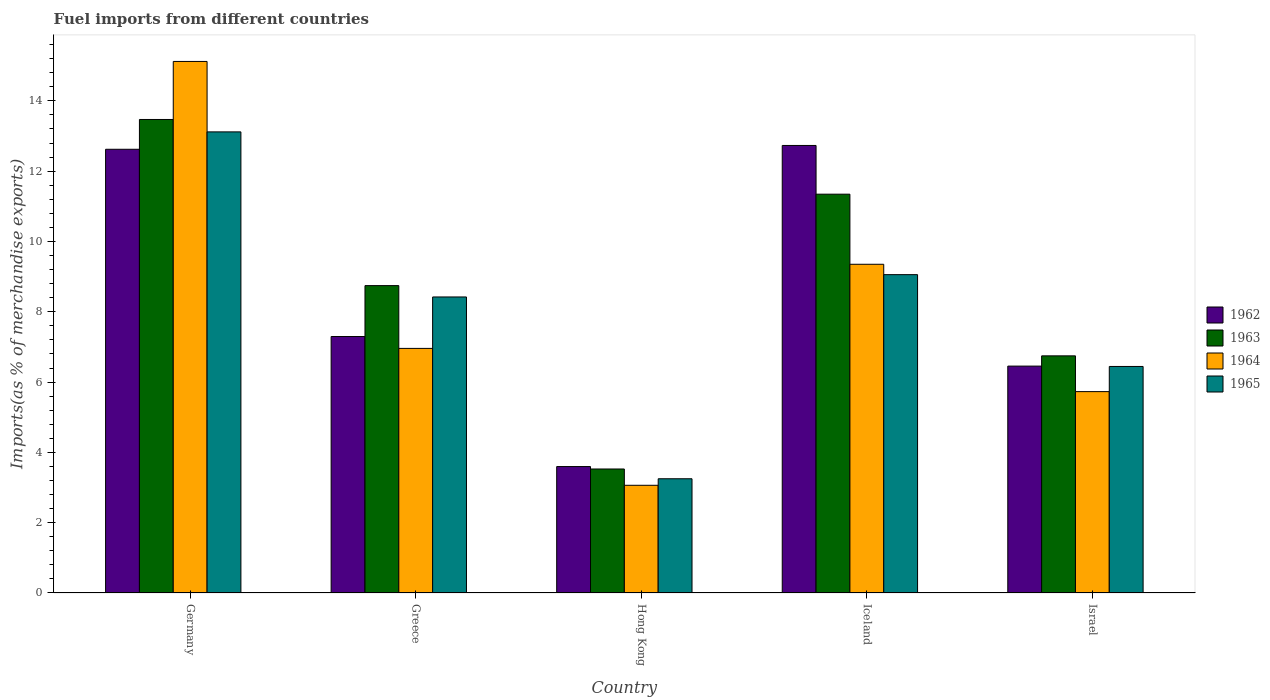How many groups of bars are there?
Offer a very short reply. 5. Are the number of bars per tick equal to the number of legend labels?
Offer a very short reply. Yes. How many bars are there on the 4th tick from the left?
Make the answer very short. 4. What is the percentage of imports to different countries in 1962 in Israel?
Make the answer very short. 6.45. Across all countries, what is the maximum percentage of imports to different countries in 1963?
Your answer should be very brief. 13.47. Across all countries, what is the minimum percentage of imports to different countries in 1964?
Offer a very short reply. 3.06. In which country was the percentage of imports to different countries in 1965 maximum?
Offer a very short reply. Germany. In which country was the percentage of imports to different countries in 1964 minimum?
Your answer should be very brief. Hong Kong. What is the total percentage of imports to different countries in 1962 in the graph?
Ensure brevity in your answer.  42.7. What is the difference between the percentage of imports to different countries in 1962 in Greece and that in Hong Kong?
Ensure brevity in your answer.  3.7. What is the difference between the percentage of imports to different countries in 1962 in Greece and the percentage of imports to different countries in 1965 in Israel?
Your answer should be compact. 0.85. What is the average percentage of imports to different countries in 1963 per country?
Your response must be concise. 8.77. What is the difference between the percentage of imports to different countries of/in 1963 and percentage of imports to different countries of/in 1965 in Hong Kong?
Ensure brevity in your answer.  0.28. In how many countries, is the percentage of imports to different countries in 1965 greater than 10 %?
Give a very brief answer. 1. What is the ratio of the percentage of imports to different countries in 1963 in Greece to that in Iceland?
Offer a terse response. 0.77. Is the difference between the percentage of imports to different countries in 1963 in Greece and Hong Kong greater than the difference between the percentage of imports to different countries in 1965 in Greece and Hong Kong?
Give a very brief answer. Yes. What is the difference between the highest and the second highest percentage of imports to different countries in 1963?
Ensure brevity in your answer.  -2.6. What is the difference between the highest and the lowest percentage of imports to different countries in 1962?
Offer a terse response. 9.13. Is it the case that in every country, the sum of the percentage of imports to different countries in 1963 and percentage of imports to different countries in 1962 is greater than the sum of percentage of imports to different countries in 1964 and percentage of imports to different countries in 1965?
Your answer should be compact. No. What does the 2nd bar from the left in Hong Kong represents?
Give a very brief answer. 1963. Are all the bars in the graph horizontal?
Provide a succinct answer. No. How many countries are there in the graph?
Provide a succinct answer. 5. Does the graph contain any zero values?
Your response must be concise. No. Where does the legend appear in the graph?
Provide a succinct answer. Center right. What is the title of the graph?
Give a very brief answer. Fuel imports from different countries. Does "2013" appear as one of the legend labels in the graph?
Provide a short and direct response. No. What is the label or title of the Y-axis?
Give a very brief answer. Imports(as % of merchandise exports). What is the Imports(as % of merchandise exports) in 1962 in Germany?
Ensure brevity in your answer.  12.62. What is the Imports(as % of merchandise exports) of 1963 in Germany?
Offer a terse response. 13.47. What is the Imports(as % of merchandise exports) in 1964 in Germany?
Your answer should be compact. 15.12. What is the Imports(as % of merchandise exports) in 1965 in Germany?
Your answer should be compact. 13.12. What is the Imports(as % of merchandise exports) in 1962 in Greece?
Your response must be concise. 7.3. What is the Imports(as % of merchandise exports) of 1963 in Greece?
Provide a succinct answer. 8.74. What is the Imports(as % of merchandise exports) in 1964 in Greece?
Make the answer very short. 6.96. What is the Imports(as % of merchandise exports) of 1965 in Greece?
Your response must be concise. 8.42. What is the Imports(as % of merchandise exports) of 1962 in Hong Kong?
Your answer should be compact. 3.6. What is the Imports(as % of merchandise exports) of 1963 in Hong Kong?
Give a very brief answer. 3.53. What is the Imports(as % of merchandise exports) in 1964 in Hong Kong?
Give a very brief answer. 3.06. What is the Imports(as % of merchandise exports) in 1965 in Hong Kong?
Make the answer very short. 3.25. What is the Imports(as % of merchandise exports) in 1962 in Iceland?
Make the answer very short. 12.73. What is the Imports(as % of merchandise exports) of 1963 in Iceland?
Provide a short and direct response. 11.35. What is the Imports(as % of merchandise exports) in 1964 in Iceland?
Your answer should be very brief. 9.35. What is the Imports(as % of merchandise exports) of 1965 in Iceland?
Offer a very short reply. 9.06. What is the Imports(as % of merchandise exports) of 1962 in Israel?
Your answer should be very brief. 6.45. What is the Imports(as % of merchandise exports) in 1963 in Israel?
Your answer should be compact. 6.75. What is the Imports(as % of merchandise exports) in 1964 in Israel?
Provide a succinct answer. 5.73. What is the Imports(as % of merchandise exports) of 1965 in Israel?
Keep it short and to the point. 6.44. Across all countries, what is the maximum Imports(as % of merchandise exports) in 1962?
Offer a terse response. 12.73. Across all countries, what is the maximum Imports(as % of merchandise exports) in 1963?
Your answer should be very brief. 13.47. Across all countries, what is the maximum Imports(as % of merchandise exports) of 1964?
Ensure brevity in your answer.  15.12. Across all countries, what is the maximum Imports(as % of merchandise exports) of 1965?
Offer a terse response. 13.12. Across all countries, what is the minimum Imports(as % of merchandise exports) in 1962?
Keep it short and to the point. 3.6. Across all countries, what is the minimum Imports(as % of merchandise exports) in 1963?
Make the answer very short. 3.53. Across all countries, what is the minimum Imports(as % of merchandise exports) in 1964?
Your answer should be very brief. 3.06. Across all countries, what is the minimum Imports(as % of merchandise exports) in 1965?
Ensure brevity in your answer.  3.25. What is the total Imports(as % of merchandise exports) of 1962 in the graph?
Offer a terse response. 42.7. What is the total Imports(as % of merchandise exports) in 1963 in the graph?
Your answer should be very brief. 43.83. What is the total Imports(as % of merchandise exports) of 1964 in the graph?
Provide a short and direct response. 40.22. What is the total Imports(as % of merchandise exports) of 1965 in the graph?
Your answer should be very brief. 40.29. What is the difference between the Imports(as % of merchandise exports) in 1962 in Germany and that in Greece?
Your response must be concise. 5.33. What is the difference between the Imports(as % of merchandise exports) of 1963 in Germany and that in Greece?
Ensure brevity in your answer.  4.73. What is the difference between the Imports(as % of merchandise exports) in 1964 in Germany and that in Greece?
Provide a short and direct response. 8.16. What is the difference between the Imports(as % of merchandise exports) of 1965 in Germany and that in Greece?
Offer a very short reply. 4.7. What is the difference between the Imports(as % of merchandise exports) in 1962 in Germany and that in Hong Kong?
Your response must be concise. 9.03. What is the difference between the Imports(as % of merchandise exports) in 1963 in Germany and that in Hong Kong?
Your answer should be very brief. 9.94. What is the difference between the Imports(as % of merchandise exports) of 1964 in Germany and that in Hong Kong?
Ensure brevity in your answer.  12.06. What is the difference between the Imports(as % of merchandise exports) of 1965 in Germany and that in Hong Kong?
Make the answer very short. 9.87. What is the difference between the Imports(as % of merchandise exports) of 1962 in Germany and that in Iceland?
Offer a very short reply. -0.11. What is the difference between the Imports(as % of merchandise exports) of 1963 in Germany and that in Iceland?
Provide a succinct answer. 2.13. What is the difference between the Imports(as % of merchandise exports) of 1964 in Germany and that in Iceland?
Give a very brief answer. 5.77. What is the difference between the Imports(as % of merchandise exports) in 1965 in Germany and that in Iceland?
Ensure brevity in your answer.  4.06. What is the difference between the Imports(as % of merchandise exports) of 1962 in Germany and that in Israel?
Offer a very short reply. 6.17. What is the difference between the Imports(as % of merchandise exports) of 1963 in Germany and that in Israel?
Offer a terse response. 6.72. What is the difference between the Imports(as % of merchandise exports) in 1964 in Germany and that in Israel?
Your answer should be very brief. 9.39. What is the difference between the Imports(as % of merchandise exports) of 1965 in Germany and that in Israel?
Your response must be concise. 6.67. What is the difference between the Imports(as % of merchandise exports) in 1962 in Greece and that in Hong Kong?
Provide a succinct answer. 3.7. What is the difference between the Imports(as % of merchandise exports) in 1963 in Greece and that in Hong Kong?
Offer a terse response. 5.22. What is the difference between the Imports(as % of merchandise exports) of 1964 in Greece and that in Hong Kong?
Your answer should be very brief. 3.89. What is the difference between the Imports(as % of merchandise exports) in 1965 in Greece and that in Hong Kong?
Give a very brief answer. 5.17. What is the difference between the Imports(as % of merchandise exports) in 1962 in Greece and that in Iceland?
Ensure brevity in your answer.  -5.44. What is the difference between the Imports(as % of merchandise exports) in 1963 in Greece and that in Iceland?
Ensure brevity in your answer.  -2.6. What is the difference between the Imports(as % of merchandise exports) in 1964 in Greece and that in Iceland?
Give a very brief answer. -2.39. What is the difference between the Imports(as % of merchandise exports) in 1965 in Greece and that in Iceland?
Offer a terse response. -0.64. What is the difference between the Imports(as % of merchandise exports) of 1962 in Greece and that in Israel?
Your answer should be compact. 0.84. What is the difference between the Imports(as % of merchandise exports) in 1963 in Greece and that in Israel?
Your answer should be very brief. 2. What is the difference between the Imports(as % of merchandise exports) in 1964 in Greece and that in Israel?
Ensure brevity in your answer.  1.23. What is the difference between the Imports(as % of merchandise exports) of 1965 in Greece and that in Israel?
Your answer should be compact. 1.98. What is the difference between the Imports(as % of merchandise exports) of 1962 in Hong Kong and that in Iceland?
Give a very brief answer. -9.13. What is the difference between the Imports(as % of merchandise exports) in 1963 in Hong Kong and that in Iceland?
Provide a short and direct response. -7.82. What is the difference between the Imports(as % of merchandise exports) of 1964 in Hong Kong and that in Iceland?
Your response must be concise. -6.29. What is the difference between the Imports(as % of merchandise exports) in 1965 in Hong Kong and that in Iceland?
Ensure brevity in your answer.  -5.81. What is the difference between the Imports(as % of merchandise exports) of 1962 in Hong Kong and that in Israel?
Your response must be concise. -2.86. What is the difference between the Imports(as % of merchandise exports) in 1963 in Hong Kong and that in Israel?
Provide a short and direct response. -3.22. What is the difference between the Imports(as % of merchandise exports) of 1964 in Hong Kong and that in Israel?
Offer a very short reply. -2.66. What is the difference between the Imports(as % of merchandise exports) of 1965 in Hong Kong and that in Israel?
Your answer should be very brief. -3.19. What is the difference between the Imports(as % of merchandise exports) in 1962 in Iceland and that in Israel?
Offer a very short reply. 6.28. What is the difference between the Imports(as % of merchandise exports) of 1963 in Iceland and that in Israel?
Keep it short and to the point. 4.6. What is the difference between the Imports(as % of merchandise exports) in 1964 in Iceland and that in Israel?
Offer a terse response. 3.62. What is the difference between the Imports(as % of merchandise exports) in 1965 in Iceland and that in Israel?
Give a very brief answer. 2.61. What is the difference between the Imports(as % of merchandise exports) of 1962 in Germany and the Imports(as % of merchandise exports) of 1963 in Greece?
Provide a succinct answer. 3.88. What is the difference between the Imports(as % of merchandise exports) in 1962 in Germany and the Imports(as % of merchandise exports) in 1964 in Greece?
Offer a terse response. 5.66. What is the difference between the Imports(as % of merchandise exports) in 1962 in Germany and the Imports(as % of merchandise exports) in 1965 in Greece?
Your answer should be very brief. 4.2. What is the difference between the Imports(as % of merchandise exports) in 1963 in Germany and the Imports(as % of merchandise exports) in 1964 in Greece?
Ensure brevity in your answer.  6.51. What is the difference between the Imports(as % of merchandise exports) of 1963 in Germany and the Imports(as % of merchandise exports) of 1965 in Greece?
Provide a succinct answer. 5.05. What is the difference between the Imports(as % of merchandise exports) of 1964 in Germany and the Imports(as % of merchandise exports) of 1965 in Greece?
Give a very brief answer. 6.7. What is the difference between the Imports(as % of merchandise exports) of 1962 in Germany and the Imports(as % of merchandise exports) of 1963 in Hong Kong?
Keep it short and to the point. 9.1. What is the difference between the Imports(as % of merchandise exports) of 1962 in Germany and the Imports(as % of merchandise exports) of 1964 in Hong Kong?
Your response must be concise. 9.56. What is the difference between the Imports(as % of merchandise exports) in 1962 in Germany and the Imports(as % of merchandise exports) in 1965 in Hong Kong?
Your response must be concise. 9.37. What is the difference between the Imports(as % of merchandise exports) of 1963 in Germany and the Imports(as % of merchandise exports) of 1964 in Hong Kong?
Make the answer very short. 10.41. What is the difference between the Imports(as % of merchandise exports) in 1963 in Germany and the Imports(as % of merchandise exports) in 1965 in Hong Kong?
Keep it short and to the point. 10.22. What is the difference between the Imports(as % of merchandise exports) of 1964 in Germany and the Imports(as % of merchandise exports) of 1965 in Hong Kong?
Your response must be concise. 11.87. What is the difference between the Imports(as % of merchandise exports) of 1962 in Germany and the Imports(as % of merchandise exports) of 1963 in Iceland?
Your answer should be very brief. 1.28. What is the difference between the Imports(as % of merchandise exports) in 1962 in Germany and the Imports(as % of merchandise exports) in 1964 in Iceland?
Offer a terse response. 3.27. What is the difference between the Imports(as % of merchandise exports) in 1962 in Germany and the Imports(as % of merchandise exports) in 1965 in Iceland?
Your response must be concise. 3.57. What is the difference between the Imports(as % of merchandise exports) of 1963 in Germany and the Imports(as % of merchandise exports) of 1964 in Iceland?
Ensure brevity in your answer.  4.12. What is the difference between the Imports(as % of merchandise exports) of 1963 in Germany and the Imports(as % of merchandise exports) of 1965 in Iceland?
Offer a terse response. 4.41. What is the difference between the Imports(as % of merchandise exports) in 1964 in Germany and the Imports(as % of merchandise exports) in 1965 in Iceland?
Offer a very short reply. 6.06. What is the difference between the Imports(as % of merchandise exports) of 1962 in Germany and the Imports(as % of merchandise exports) of 1963 in Israel?
Give a very brief answer. 5.88. What is the difference between the Imports(as % of merchandise exports) of 1962 in Germany and the Imports(as % of merchandise exports) of 1964 in Israel?
Offer a very short reply. 6.89. What is the difference between the Imports(as % of merchandise exports) of 1962 in Germany and the Imports(as % of merchandise exports) of 1965 in Israel?
Provide a short and direct response. 6.18. What is the difference between the Imports(as % of merchandise exports) in 1963 in Germany and the Imports(as % of merchandise exports) in 1964 in Israel?
Provide a short and direct response. 7.74. What is the difference between the Imports(as % of merchandise exports) of 1963 in Germany and the Imports(as % of merchandise exports) of 1965 in Israel?
Ensure brevity in your answer.  7.03. What is the difference between the Imports(as % of merchandise exports) in 1964 in Germany and the Imports(as % of merchandise exports) in 1965 in Israel?
Provide a succinct answer. 8.68. What is the difference between the Imports(as % of merchandise exports) in 1962 in Greece and the Imports(as % of merchandise exports) in 1963 in Hong Kong?
Give a very brief answer. 3.77. What is the difference between the Imports(as % of merchandise exports) in 1962 in Greece and the Imports(as % of merchandise exports) in 1964 in Hong Kong?
Offer a very short reply. 4.23. What is the difference between the Imports(as % of merchandise exports) in 1962 in Greece and the Imports(as % of merchandise exports) in 1965 in Hong Kong?
Offer a terse response. 4.05. What is the difference between the Imports(as % of merchandise exports) in 1963 in Greece and the Imports(as % of merchandise exports) in 1964 in Hong Kong?
Offer a very short reply. 5.68. What is the difference between the Imports(as % of merchandise exports) in 1963 in Greece and the Imports(as % of merchandise exports) in 1965 in Hong Kong?
Offer a very short reply. 5.49. What is the difference between the Imports(as % of merchandise exports) of 1964 in Greece and the Imports(as % of merchandise exports) of 1965 in Hong Kong?
Keep it short and to the point. 3.71. What is the difference between the Imports(as % of merchandise exports) of 1962 in Greece and the Imports(as % of merchandise exports) of 1963 in Iceland?
Provide a succinct answer. -4.05. What is the difference between the Imports(as % of merchandise exports) in 1962 in Greece and the Imports(as % of merchandise exports) in 1964 in Iceland?
Your response must be concise. -2.06. What is the difference between the Imports(as % of merchandise exports) of 1962 in Greece and the Imports(as % of merchandise exports) of 1965 in Iceland?
Your answer should be compact. -1.76. What is the difference between the Imports(as % of merchandise exports) in 1963 in Greece and the Imports(as % of merchandise exports) in 1964 in Iceland?
Your answer should be very brief. -0.61. What is the difference between the Imports(as % of merchandise exports) in 1963 in Greece and the Imports(as % of merchandise exports) in 1965 in Iceland?
Provide a succinct answer. -0.31. What is the difference between the Imports(as % of merchandise exports) of 1964 in Greece and the Imports(as % of merchandise exports) of 1965 in Iceland?
Ensure brevity in your answer.  -2.1. What is the difference between the Imports(as % of merchandise exports) in 1962 in Greece and the Imports(as % of merchandise exports) in 1963 in Israel?
Your answer should be very brief. 0.55. What is the difference between the Imports(as % of merchandise exports) in 1962 in Greece and the Imports(as % of merchandise exports) in 1964 in Israel?
Your answer should be very brief. 1.57. What is the difference between the Imports(as % of merchandise exports) of 1962 in Greece and the Imports(as % of merchandise exports) of 1965 in Israel?
Give a very brief answer. 0.85. What is the difference between the Imports(as % of merchandise exports) in 1963 in Greece and the Imports(as % of merchandise exports) in 1964 in Israel?
Your response must be concise. 3.02. What is the difference between the Imports(as % of merchandise exports) in 1964 in Greece and the Imports(as % of merchandise exports) in 1965 in Israel?
Keep it short and to the point. 0.51. What is the difference between the Imports(as % of merchandise exports) of 1962 in Hong Kong and the Imports(as % of merchandise exports) of 1963 in Iceland?
Your response must be concise. -7.75. What is the difference between the Imports(as % of merchandise exports) of 1962 in Hong Kong and the Imports(as % of merchandise exports) of 1964 in Iceland?
Provide a succinct answer. -5.75. What is the difference between the Imports(as % of merchandise exports) in 1962 in Hong Kong and the Imports(as % of merchandise exports) in 1965 in Iceland?
Provide a succinct answer. -5.46. What is the difference between the Imports(as % of merchandise exports) of 1963 in Hong Kong and the Imports(as % of merchandise exports) of 1964 in Iceland?
Provide a succinct answer. -5.82. What is the difference between the Imports(as % of merchandise exports) of 1963 in Hong Kong and the Imports(as % of merchandise exports) of 1965 in Iceland?
Give a very brief answer. -5.53. What is the difference between the Imports(as % of merchandise exports) in 1964 in Hong Kong and the Imports(as % of merchandise exports) in 1965 in Iceland?
Offer a very short reply. -5.99. What is the difference between the Imports(as % of merchandise exports) in 1962 in Hong Kong and the Imports(as % of merchandise exports) in 1963 in Israel?
Your response must be concise. -3.15. What is the difference between the Imports(as % of merchandise exports) of 1962 in Hong Kong and the Imports(as % of merchandise exports) of 1964 in Israel?
Ensure brevity in your answer.  -2.13. What is the difference between the Imports(as % of merchandise exports) in 1962 in Hong Kong and the Imports(as % of merchandise exports) in 1965 in Israel?
Make the answer very short. -2.85. What is the difference between the Imports(as % of merchandise exports) of 1963 in Hong Kong and the Imports(as % of merchandise exports) of 1964 in Israel?
Ensure brevity in your answer.  -2.2. What is the difference between the Imports(as % of merchandise exports) of 1963 in Hong Kong and the Imports(as % of merchandise exports) of 1965 in Israel?
Offer a very short reply. -2.92. What is the difference between the Imports(as % of merchandise exports) of 1964 in Hong Kong and the Imports(as % of merchandise exports) of 1965 in Israel?
Offer a very short reply. -3.38. What is the difference between the Imports(as % of merchandise exports) in 1962 in Iceland and the Imports(as % of merchandise exports) in 1963 in Israel?
Offer a terse response. 5.99. What is the difference between the Imports(as % of merchandise exports) of 1962 in Iceland and the Imports(as % of merchandise exports) of 1964 in Israel?
Give a very brief answer. 7. What is the difference between the Imports(as % of merchandise exports) of 1962 in Iceland and the Imports(as % of merchandise exports) of 1965 in Israel?
Provide a succinct answer. 6.29. What is the difference between the Imports(as % of merchandise exports) in 1963 in Iceland and the Imports(as % of merchandise exports) in 1964 in Israel?
Provide a short and direct response. 5.62. What is the difference between the Imports(as % of merchandise exports) of 1963 in Iceland and the Imports(as % of merchandise exports) of 1965 in Israel?
Make the answer very short. 4.9. What is the difference between the Imports(as % of merchandise exports) of 1964 in Iceland and the Imports(as % of merchandise exports) of 1965 in Israel?
Your answer should be compact. 2.91. What is the average Imports(as % of merchandise exports) of 1962 per country?
Provide a succinct answer. 8.54. What is the average Imports(as % of merchandise exports) of 1963 per country?
Your answer should be compact. 8.77. What is the average Imports(as % of merchandise exports) of 1964 per country?
Give a very brief answer. 8.04. What is the average Imports(as % of merchandise exports) of 1965 per country?
Ensure brevity in your answer.  8.06. What is the difference between the Imports(as % of merchandise exports) in 1962 and Imports(as % of merchandise exports) in 1963 in Germany?
Your answer should be very brief. -0.85. What is the difference between the Imports(as % of merchandise exports) of 1962 and Imports(as % of merchandise exports) of 1964 in Germany?
Your answer should be compact. -2.5. What is the difference between the Imports(as % of merchandise exports) of 1962 and Imports(as % of merchandise exports) of 1965 in Germany?
Provide a succinct answer. -0.49. What is the difference between the Imports(as % of merchandise exports) of 1963 and Imports(as % of merchandise exports) of 1964 in Germany?
Offer a terse response. -1.65. What is the difference between the Imports(as % of merchandise exports) of 1963 and Imports(as % of merchandise exports) of 1965 in Germany?
Keep it short and to the point. 0.35. What is the difference between the Imports(as % of merchandise exports) of 1964 and Imports(as % of merchandise exports) of 1965 in Germany?
Provide a short and direct response. 2. What is the difference between the Imports(as % of merchandise exports) in 1962 and Imports(as % of merchandise exports) in 1963 in Greece?
Provide a short and direct response. -1.45. What is the difference between the Imports(as % of merchandise exports) of 1962 and Imports(as % of merchandise exports) of 1964 in Greece?
Your answer should be very brief. 0.34. What is the difference between the Imports(as % of merchandise exports) in 1962 and Imports(as % of merchandise exports) in 1965 in Greece?
Your response must be concise. -1.13. What is the difference between the Imports(as % of merchandise exports) of 1963 and Imports(as % of merchandise exports) of 1964 in Greece?
Provide a succinct answer. 1.79. What is the difference between the Imports(as % of merchandise exports) of 1963 and Imports(as % of merchandise exports) of 1965 in Greece?
Your answer should be compact. 0.32. What is the difference between the Imports(as % of merchandise exports) of 1964 and Imports(as % of merchandise exports) of 1965 in Greece?
Your answer should be very brief. -1.46. What is the difference between the Imports(as % of merchandise exports) of 1962 and Imports(as % of merchandise exports) of 1963 in Hong Kong?
Give a very brief answer. 0.07. What is the difference between the Imports(as % of merchandise exports) of 1962 and Imports(as % of merchandise exports) of 1964 in Hong Kong?
Your response must be concise. 0.53. What is the difference between the Imports(as % of merchandise exports) of 1962 and Imports(as % of merchandise exports) of 1965 in Hong Kong?
Provide a succinct answer. 0.35. What is the difference between the Imports(as % of merchandise exports) of 1963 and Imports(as % of merchandise exports) of 1964 in Hong Kong?
Your answer should be very brief. 0.46. What is the difference between the Imports(as % of merchandise exports) of 1963 and Imports(as % of merchandise exports) of 1965 in Hong Kong?
Your answer should be very brief. 0.28. What is the difference between the Imports(as % of merchandise exports) in 1964 and Imports(as % of merchandise exports) in 1965 in Hong Kong?
Your answer should be very brief. -0.19. What is the difference between the Imports(as % of merchandise exports) in 1962 and Imports(as % of merchandise exports) in 1963 in Iceland?
Your response must be concise. 1.39. What is the difference between the Imports(as % of merchandise exports) of 1962 and Imports(as % of merchandise exports) of 1964 in Iceland?
Your answer should be very brief. 3.38. What is the difference between the Imports(as % of merchandise exports) of 1962 and Imports(as % of merchandise exports) of 1965 in Iceland?
Ensure brevity in your answer.  3.67. What is the difference between the Imports(as % of merchandise exports) of 1963 and Imports(as % of merchandise exports) of 1964 in Iceland?
Provide a short and direct response. 1.99. What is the difference between the Imports(as % of merchandise exports) in 1963 and Imports(as % of merchandise exports) in 1965 in Iceland?
Offer a terse response. 2.29. What is the difference between the Imports(as % of merchandise exports) in 1964 and Imports(as % of merchandise exports) in 1965 in Iceland?
Offer a terse response. 0.29. What is the difference between the Imports(as % of merchandise exports) in 1962 and Imports(as % of merchandise exports) in 1963 in Israel?
Keep it short and to the point. -0.29. What is the difference between the Imports(as % of merchandise exports) in 1962 and Imports(as % of merchandise exports) in 1964 in Israel?
Offer a very short reply. 0.73. What is the difference between the Imports(as % of merchandise exports) of 1962 and Imports(as % of merchandise exports) of 1965 in Israel?
Provide a succinct answer. 0.01. What is the difference between the Imports(as % of merchandise exports) of 1963 and Imports(as % of merchandise exports) of 1964 in Israel?
Provide a short and direct response. 1.02. What is the difference between the Imports(as % of merchandise exports) of 1963 and Imports(as % of merchandise exports) of 1965 in Israel?
Provide a short and direct response. 0.3. What is the difference between the Imports(as % of merchandise exports) in 1964 and Imports(as % of merchandise exports) in 1965 in Israel?
Give a very brief answer. -0.72. What is the ratio of the Imports(as % of merchandise exports) in 1962 in Germany to that in Greece?
Offer a very short reply. 1.73. What is the ratio of the Imports(as % of merchandise exports) of 1963 in Germany to that in Greece?
Make the answer very short. 1.54. What is the ratio of the Imports(as % of merchandise exports) in 1964 in Germany to that in Greece?
Ensure brevity in your answer.  2.17. What is the ratio of the Imports(as % of merchandise exports) in 1965 in Germany to that in Greece?
Your answer should be very brief. 1.56. What is the ratio of the Imports(as % of merchandise exports) in 1962 in Germany to that in Hong Kong?
Provide a short and direct response. 3.51. What is the ratio of the Imports(as % of merchandise exports) of 1963 in Germany to that in Hong Kong?
Give a very brief answer. 3.82. What is the ratio of the Imports(as % of merchandise exports) in 1964 in Germany to that in Hong Kong?
Your answer should be compact. 4.94. What is the ratio of the Imports(as % of merchandise exports) in 1965 in Germany to that in Hong Kong?
Provide a short and direct response. 4.04. What is the ratio of the Imports(as % of merchandise exports) of 1962 in Germany to that in Iceland?
Keep it short and to the point. 0.99. What is the ratio of the Imports(as % of merchandise exports) of 1963 in Germany to that in Iceland?
Ensure brevity in your answer.  1.19. What is the ratio of the Imports(as % of merchandise exports) in 1964 in Germany to that in Iceland?
Give a very brief answer. 1.62. What is the ratio of the Imports(as % of merchandise exports) of 1965 in Germany to that in Iceland?
Your response must be concise. 1.45. What is the ratio of the Imports(as % of merchandise exports) of 1962 in Germany to that in Israel?
Ensure brevity in your answer.  1.96. What is the ratio of the Imports(as % of merchandise exports) of 1963 in Germany to that in Israel?
Offer a very short reply. 2. What is the ratio of the Imports(as % of merchandise exports) of 1964 in Germany to that in Israel?
Your answer should be compact. 2.64. What is the ratio of the Imports(as % of merchandise exports) of 1965 in Germany to that in Israel?
Give a very brief answer. 2.04. What is the ratio of the Imports(as % of merchandise exports) of 1962 in Greece to that in Hong Kong?
Provide a succinct answer. 2.03. What is the ratio of the Imports(as % of merchandise exports) of 1963 in Greece to that in Hong Kong?
Make the answer very short. 2.48. What is the ratio of the Imports(as % of merchandise exports) in 1964 in Greece to that in Hong Kong?
Offer a very short reply. 2.27. What is the ratio of the Imports(as % of merchandise exports) of 1965 in Greece to that in Hong Kong?
Provide a short and direct response. 2.59. What is the ratio of the Imports(as % of merchandise exports) in 1962 in Greece to that in Iceland?
Give a very brief answer. 0.57. What is the ratio of the Imports(as % of merchandise exports) in 1963 in Greece to that in Iceland?
Offer a terse response. 0.77. What is the ratio of the Imports(as % of merchandise exports) in 1964 in Greece to that in Iceland?
Offer a terse response. 0.74. What is the ratio of the Imports(as % of merchandise exports) in 1965 in Greece to that in Iceland?
Your answer should be very brief. 0.93. What is the ratio of the Imports(as % of merchandise exports) in 1962 in Greece to that in Israel?
Offer a very short reply. 1.13. What is the ratio of the Imports(as % of merchandise exports) of 1963 in Greece to that in Israel?
Your answer should be very brief. 1.3. What is the ratio of the Imports(as % of merchandise exports) of 1964 in Greece to that in Israel?
Your answer should be compact. 1.21. What is the ratio of the Imports(as % of merchandise exports) in 1965 in Greece to that in Israel?
Keep it short and to the point. 1.31. What is the ratio of the Imports(as % of merchandise exports) of 1962 in Hong Kong to that in Iceland?
Keep it short and to the point. 0.28. What is the ratio of the Imports(as % of merchandise exports) of 1963 in Hong Kong to that in Iceland?
Offer a very short reply. 0.31. What is the ratio of the Imports(as % of merchandise exports) in 1964 in Hong Kong to that in Iceland?
Give a very brief answer. 0.33. What is the ratio of the Imports(as % of merchandise exports) of 1965 in Hong Kong to that in Iceland?
Your answer should be very brief. 0.36. What is the ratio of the Imports(as % of merchandise exports) in 1962 in Hong Kong to that in Israel?
Make the answer very short. 0.56. What is the ratio of the Imports(as % of merchandise exports) in 1963 in Hong Kong to that in Israel?
Keep it short and to the point. 0.52. What is the ratio of the Imports(as % of merchandise exports) in 1964 in Hong Kong to that in Israel?
Give a very brief answer. 0.53. What is the ratio of the Imports(as % of merchandise exports) of 1965 in Hong Kong to that in Israel?
Offer a terse response. 0.5. What is the ratio of the Imports(as % of merchandise exports) of 1962 in Iceland to that in Israel?
Provide a short and direct response. 1.97. What is the ratio of the Imports(as % of merchandise exports) in 1963 in Iceland to that in Israel?
Offer a very short reply. 1.68. What is the ratio of the Imports(as % of merchandise exports) of 1964 in Iceland to that in Israel?
Keep it short and to the point. 1.63. What is the ratio of the Imports(as % of merchandise exports) of 1965 in Iceland to that in Israel?
Provide a succinct answer. 1.41. What is the difference between the highest and the second highest Imports(as % of merchandise exports) of 1962?
Your answer should be very brief. 0.11. What is the difference between the highest and the second highest Imports(as % of merchandise exports) of 1963?
Ensure brevity in your answer.  2.13. What is the difference between the highest and the second highest Imports(as % of merchandise exports) in 1964?
Your response must be concise. 5.77. What is the difference between the highest and the second highest Imports(as % of merchandise exports) of 1965?
Ensure brevity in your answer.  4.06. What is the difference between the highest and the lowest Imports(as % of merchandise exports) of 1962?
Keep it short and to the point. 9.13. What is the difference between the highest and the lowest Imports(as % of merchandise exports) in 1963?
Ensure brevity in your answer.  9.94. What is the difference between the highest and the lowest Imports(as % of merchandise exports) of 1964?
Your answer should be very brief. 12.06. What is the difference between the highest and the lowest Imports(as % of merchandise exports) in 1965?
Offer a very short reply. 9.87. 